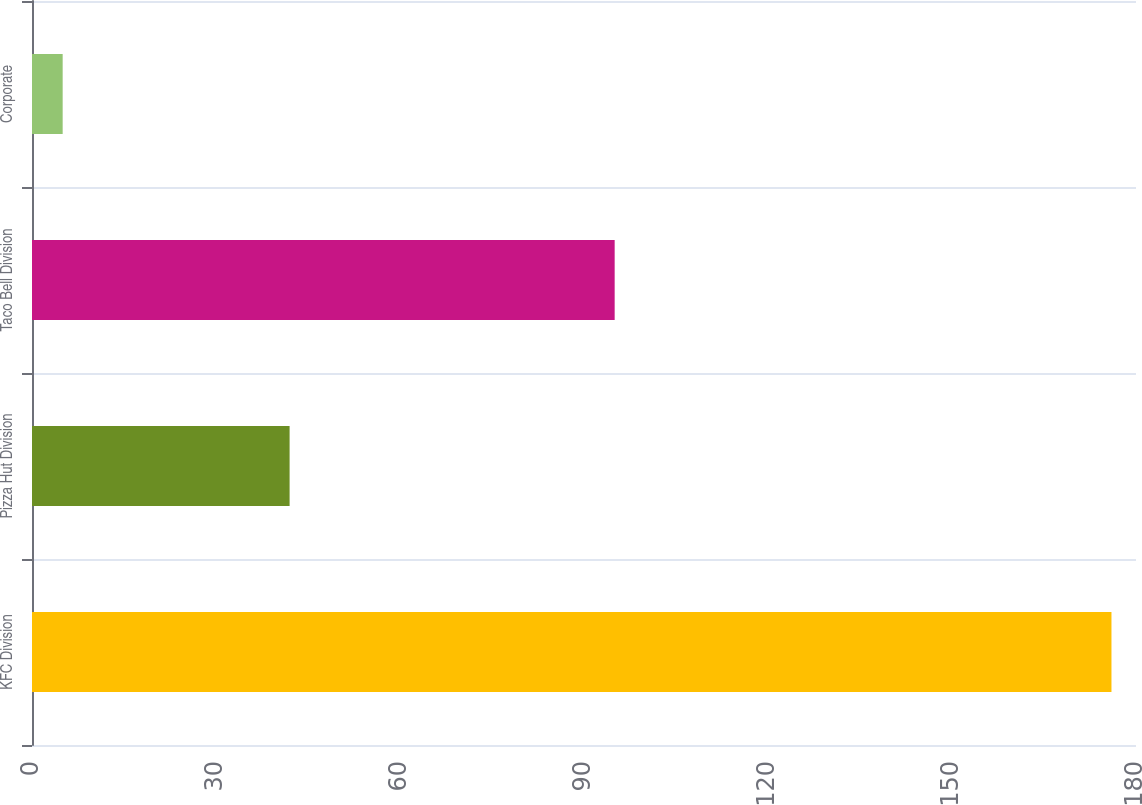<chart> <loc_0><loc_0><loc_500><loc_500><bar_chart><fcel>KFC Division<fcel>Pizza Hut Division<fcel>Taco Bell Division<fcel>Corporate<nl><fcel>176<fcel>42<fcel>95<fcel>5<nl></chart> 